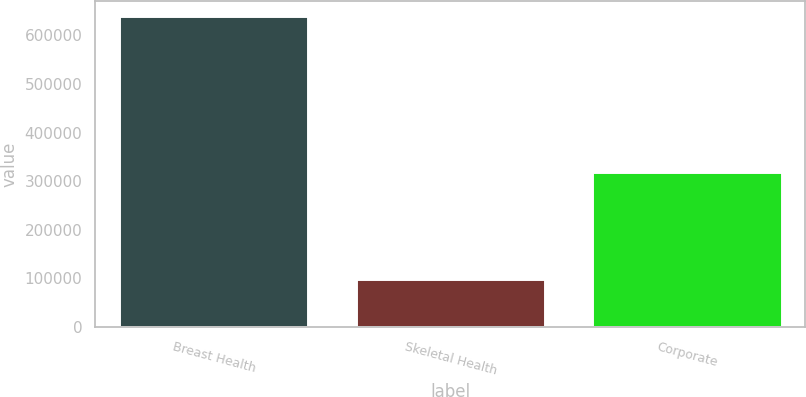<chart> <loc_0><loc_0><loc_500><loc_500><bar_chart><fcel>Breast Health<fcel>Skeletal Health<fcel>Corporate<nl><fcel>638898<fcel>99470<fcel>318663<nl></chart> 